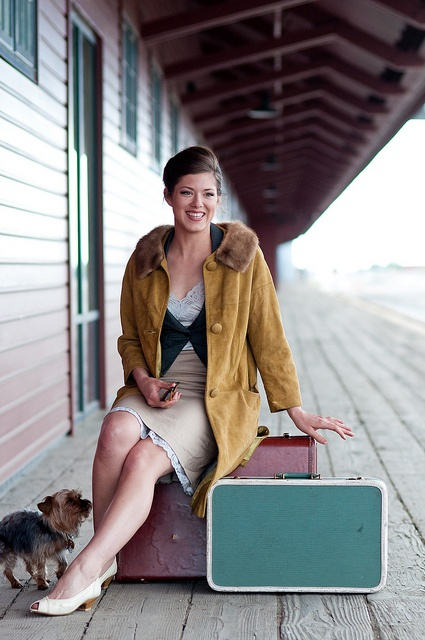Describe the objects in this image and their specific colors. I can see people in darkgray, gray, lightgray, maroon, and black tones, suitcase in darkgray and teal tones, suitcase in darkgray, purple, maroon, and black tones, and dog in darkgray, black, gray, and maroon tones in this image. 